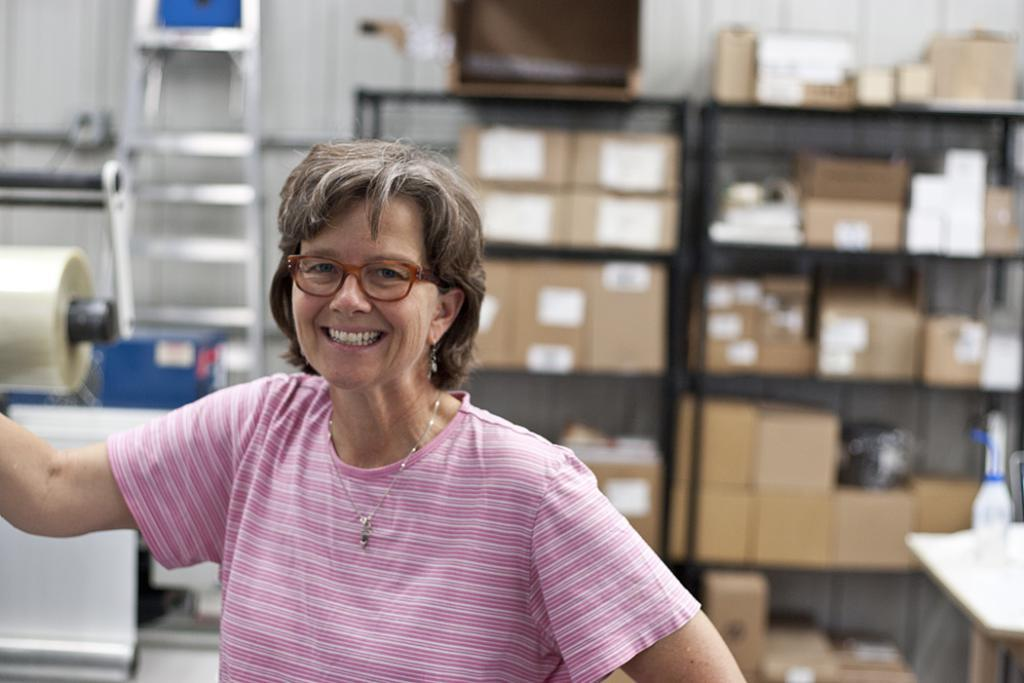Who is present in the image? There is a woman in the image. What is the woman's facial expression? The woman is smiling. What accessory is the woman wearing? The woman is wearing spectacles. What can be seen in the background of the image? There are racks, boxes, a table, a bottle, a ladder, and a wall in the background of the image. What type of cloud can be seen in the image? There is no cloud visible in the image; it is an indoor scene with a woman and various objects in the background. 